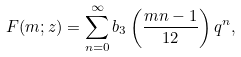<formula> <loc_0><loc_0><loc_500><loc_500>F ( m ; z ) = \sum _ { n = 0 } ^ { \infty } b _ { 3 } \left ( \frac { m n - 1 } { 1 2 } \right ) q ^ { n } ,</formula> 